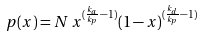Convert formula to latex. <formula><loc_0><loc_0><loc_500><loc_500>p ( x ) = N \, x ^ { ( \frac { k _ { a } } { k _ { p } } - 1 ) } ( 1 - x ) ^ { ( \frac { k _ { d } } { k _ { p } } - 1 ) }</formula> 